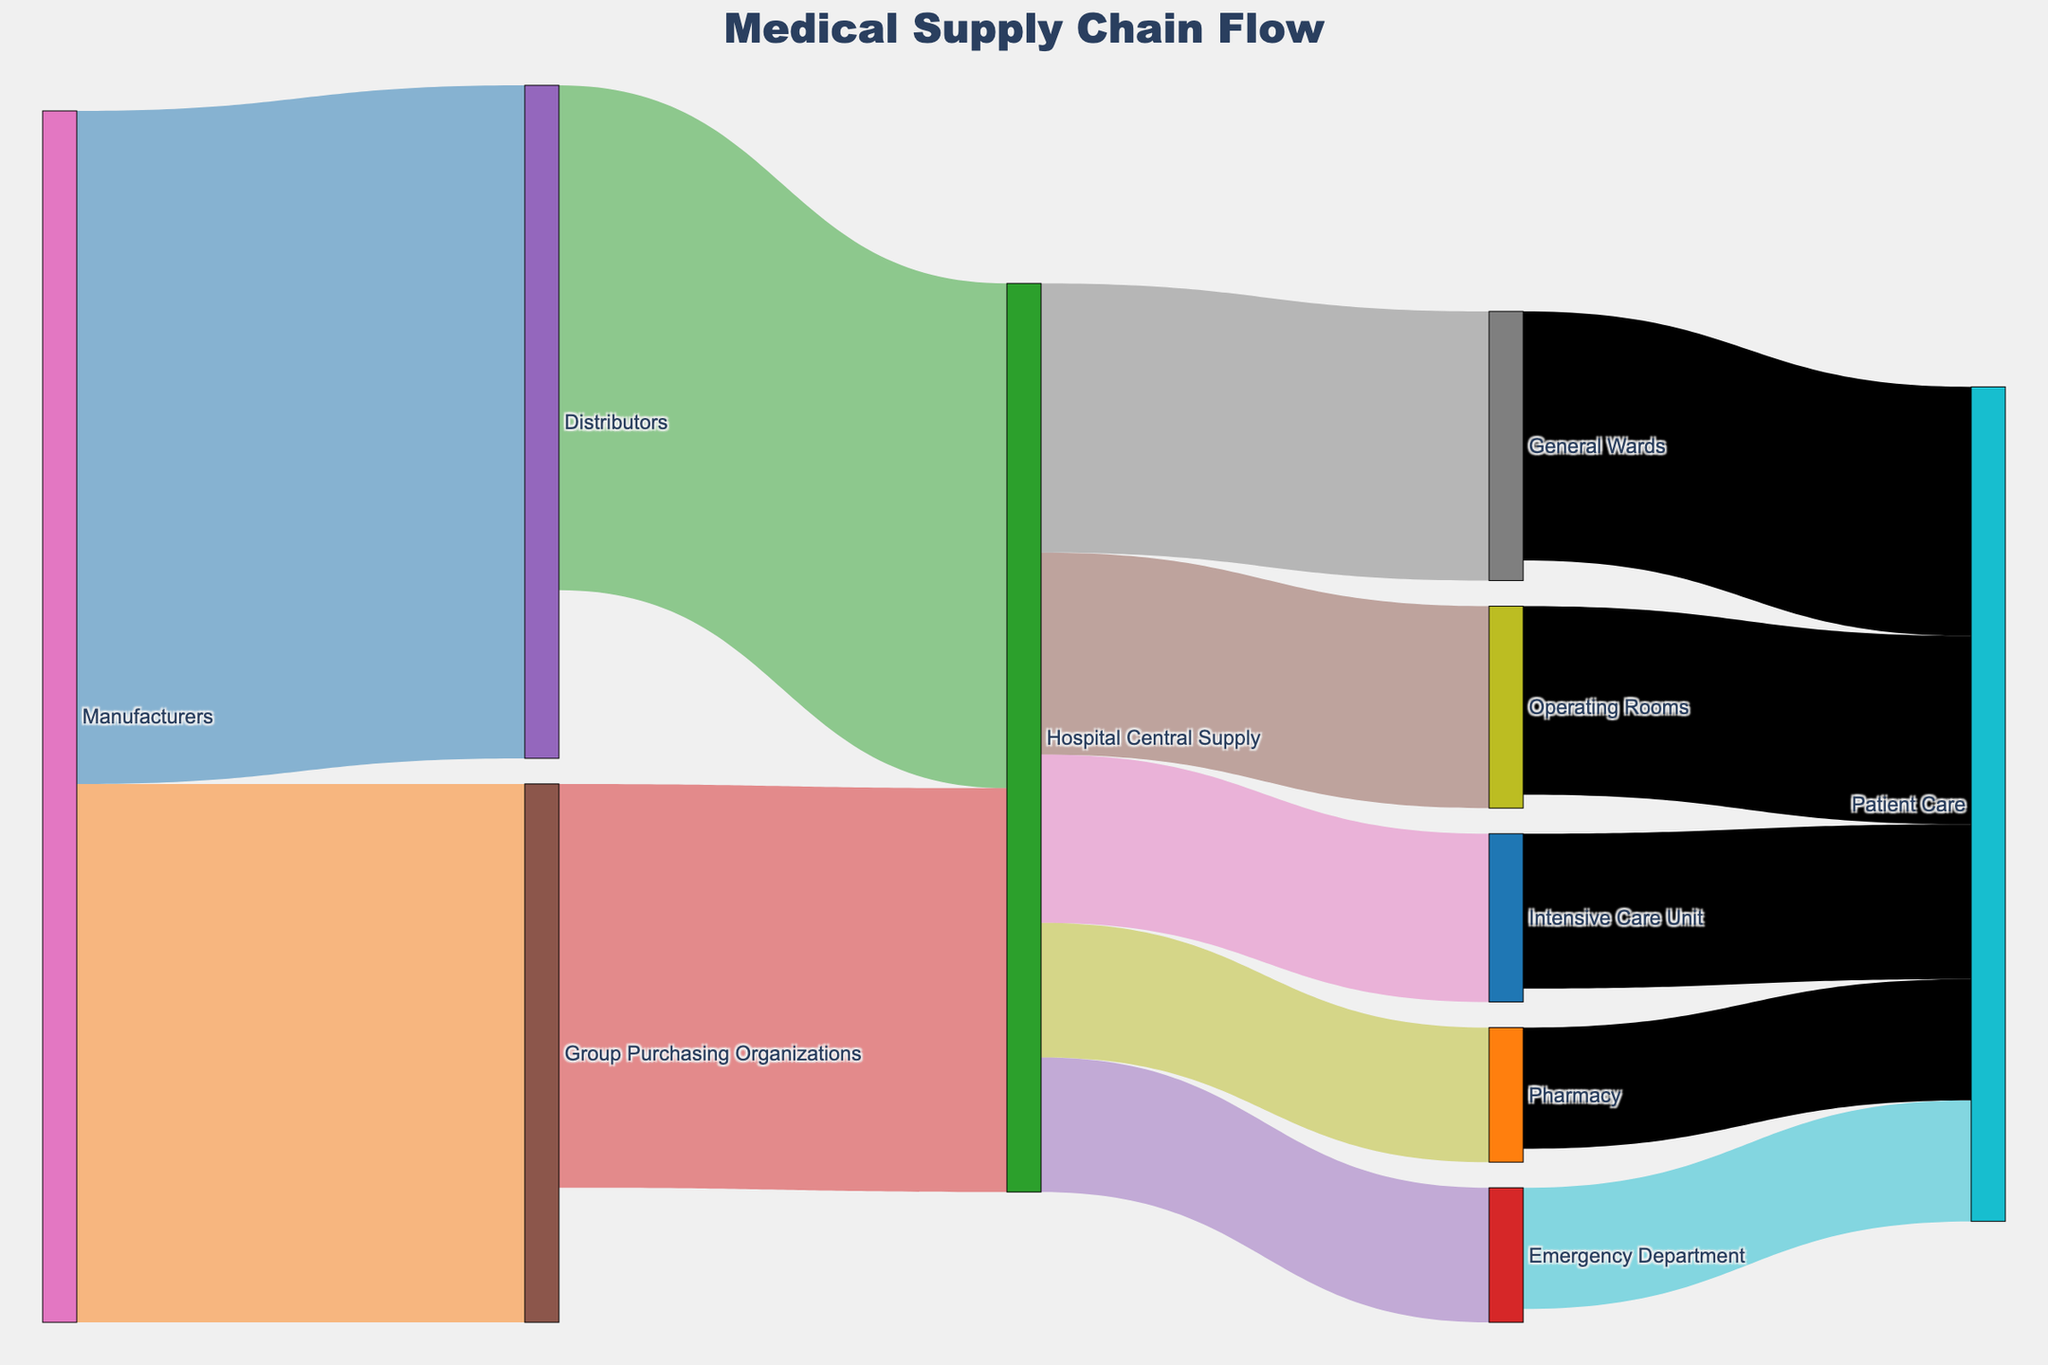what is the title of the figure? The title is written at the top center of the figure and it describes what the visualization is about. The title for this Sankey diagram is "Medical Supply Chain Flow".
Answer: Medical Supply Chain Flow How many paths lead from Manufacturers to the Hospital Central Supply? A path is a route from a source to a target. From Manufacturers, there are two paths leading to the Hospital Central Supply: one through Distributors and one through Group Purchasing Organizations.
Answer: 2 Which department receives the highest amount of supply from the Hospital Central Supply? By tracing the links from the Hospital Central Supply, we can observe the values. The department with the highest value is the General Wards, receiving 400 units.
Answer: General Wards What is the total amount of supplies received by the Hospital Central Supply? To find the total amount received by the Hospital Central Supply, we sum the values coming into it: 750 from Distributors and 600 from Group Purchasing Organizations. This gives us 750 + 600 = 1350 units.
Answer: 1350 units How does the amount of supplies to the Pharmacy compare to that to the Emergency Department from the Hospital Central Supply? We compare the values directed from the Hospital Central Supply to the Pharmacy and the Emergency Department. Pharmacy receives 200 units and the Emergency Department also receives 200 units.
Answer: Equal What is the total amount of supplies that end up in Patient Care? To find the total supplies in Patient Care, sum the values coming into it from all departments: 180 from the Emergency Department, 280 from Operating Rooms, 230 from the Intensive Care Unit, 370 from General Wards, and 180 from Pharmacy. This gives us 180 + 280 + 230 + 370 + 180 = 1240 units.
Answer: 1240 units Identify which link has the highest value in the figure? Observing the figure, the link with the highest value is from Manufacturers to Distributors, with a value of 1000 units.
Answer: Manufacturers to Distributors Are there any two links from a source to different targets that have the same value? By reviewing the figure, we see that the Hospital Central Supply sends 200 units each to the Pharmacy and the Emergency Department, which are the same value.
Answer: Yes, to Pharmacy and Emergency Department What percentage of the total supply from the Hospital Central Supply goes to the Operating Rooms? First, sum all the supplies going out from the Hospital Central Supply: 200 + 300 + 250 + 400 + 200 = 1350 units. Then, the value to the Operating Rooms is 300 units. Calculate the percentage as (300 / 1350) * 100 = 22.22%.
Answer: 22.22% How many departments receive supplies directly from the Hospital Central Supply? By counting the number of unique targets originating directly from Hospital Central Supply, we find there are five departments receiving supplies directly: Emergency Department, Operating Rooms, Intensive Care Unit, General Wards, and Pharmacy.
Answer: 5 